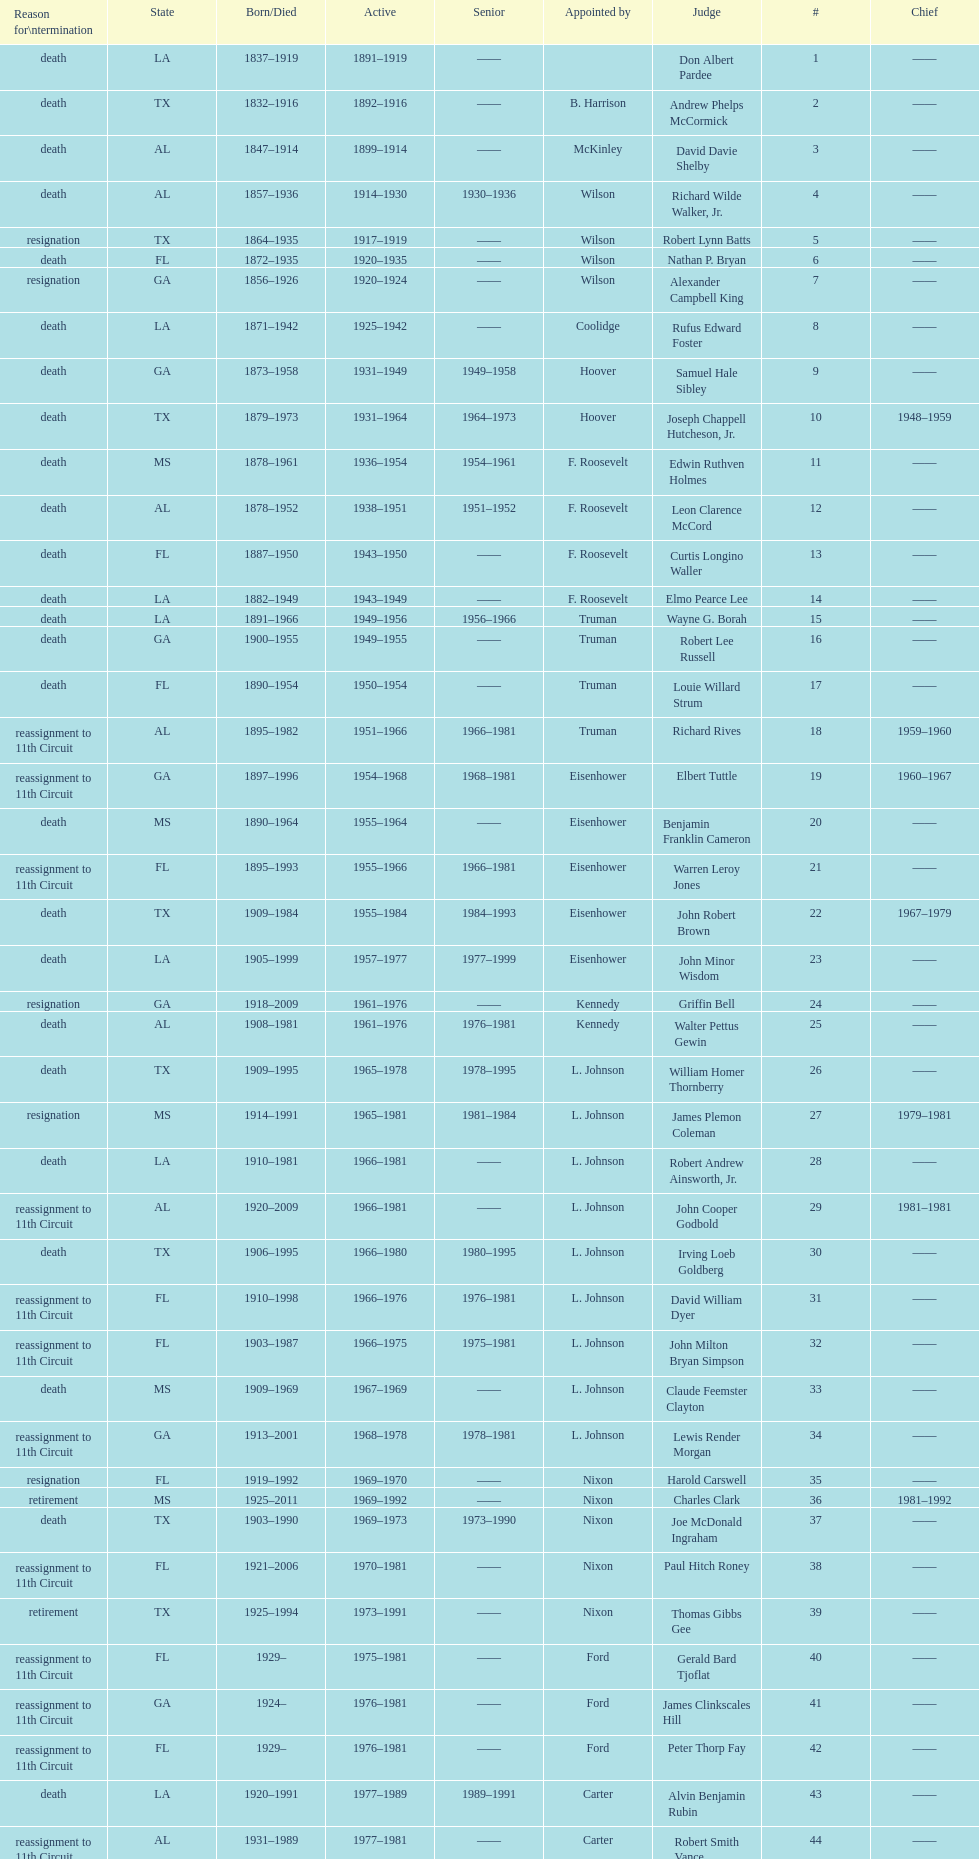Who was the first judge from florida to serve the position? Nathan P. Bryan. I'm looking to parse the entire table for insights. Could you assist me with that? {'header': ['Reason for\\ntermination', 'State', 'Born/Died', 'Active', 'Senior', 'Appointed by', 'Judge', '#', 'Chief'], 'rows': [['death', 'LA', '1837–1919', '1891–1919', '——', '', 'Don Albert Pardee', '1', '——'], ['death', 'TX', '1832–1916', '1892–1916', '——', 'B. Harrison', 'Andrew Phelps McCormick', '2', '——'], ['death', 'AL', '1847–1914', '1899–1914', '——', 'McKinley', 'David Davie Shelby', '3', '——'], ['death', 'AL', '1857–1936', '1914–1930', '1930–1936', 'Wilson', 'Richard Wilde Walker, Jr.', '4', '——'], ['resignation', 'TX', '1864–1935', '1917–1919', '——', 'Wilson', 'Robert Lynn Batts', '5', '——'], ['death', 'FL', '1872–1935', '1920–1935', '——', 'Wilson', 'Nathan P. Bryan', '6', '——'], ['resignation', 'GA', '1856–1926', '1920–1924', '——', 'Wilson', 'Alexander Campbell King', '7', '——'], ['death', 'LA', '1871–1942', '1925–1942', '——', 'Coolidge', 'Rufus Edward Foster', '8', '——'], ['death', 'GA', '1873–1958', '1931–1949', '1949–1958', 'Hoover', 'Samuel Hale Sibley', '9', '——'], ['death', 'TX', '1879–1973', '1931–1964', '1964–1973', 'Hoover', 'Joseph Chappell Hutcheson, Jr.', '10', '1948–1959'], ['death', 'MS', '1878–1961', '1936–1954', '1954–1961', 'F. Roosevelt', 'Edwin Ruthven Holmes', '11', '——'], ['death', 'AL', '1878–1952', '1938–1951', '1951–1952', 'F. Roosevelt', 'Leon Clarence McCord', '12', '——'], ['death', 'FL', '1887–1950', '1943–1950', '——', 'F. Roosevelt', 'Curtis Longino Waller', '13', '——'], ['death', 'LA', '1882–1949', '1943–1949', '——', 'F. Roosevelt', 'Elmo Pearce Lee', '14', '——'], ['death', 'LA', '1891–1966', '1949–1956', '1956–1966', 'Truman', 'Wayne G. Borah', '15', '——'], ['death', 'GA', '1900–1955', '1949–1955', '——', 'Truman', 'Robert Lee Russell', '16', '——'], ['death', 'FL', '1890–1954', '1950–1954', '——', 'Truman', 'Louie Willard Strum', '17', '——'], ['reassignment to 11th Circuit', 'AL', '1895–1982', '1951–1966', '1966–1981', 'Truman', 'Richard Rives', '18', '1959–1960'], ['reassignment to 11th Circuit', 'GA', '1897–1996', '1954–1968', '1968–1981', 'Eisenhower', 'Elbert Tuttle', '19', '1960–1967'], ['death', 'MS', '1890–1964', '1955–1964', '——', 'Eisenhower', 'Benjamin Franklin Cameron', '20', '——'], ['reassignment to 11th Circuit', 'FL', '1895–1993', '1955–1966', '1966–1981', 'Eisenhower', 'Warren Leroy Jones', '21', '——'], ['death', 'TX', '1909–1984', '1955–1984', '1984–1993', 'Eisenhower', 'John Robert Brown', '22', '1967–1979'], ['death', 'LA', '1905–1999', '1957–1977', '1977–1999', 'Eisenhower', 'John Minor Wisdom', '23', '——'], ['resignation', 'GA', '1918–2009', '1961–1976', '——', 'Kennedy', 'Griffin Bell', '24', '——'], ['death', 'AL', '1908–1981', '1961–1976', '1976–1981', 'Kennedy', 'Walter Pettus Gewin', '25', '——'], ['death', 'TX', '1909–1995', '1965–1978', '1978–1995', 'L. Johnson', 'William Homer Thornberry', '26', '——'], ['resignation', 'MS', '1914–1991', '1965–1981', '1981–1984', 'L. Johnson', 'James Plemon Coleman', '27', '1979–1981'], ['death', 'LA', '1910–1981', '1966–1981', '——', 'L. Johnson', 'Robert Andrew Ainsworth, Jr.', '28', '——'], ['reassignment to 11th Circuit', 'AL', '1920–2009', '1966–1981', '——', 'L. Johnson', 'John Cooper Godbold', '29', '1981–1981'], ['death', 'TX', '1906–1995', '1966–1980', '1980–1995', 'L. Johnson', 'Irving Loeb Goldberg', '30', '——'], ['reassignment to 11th Circuit', 'FL', '1910–1998', '1966–1976', '1976–1981', 'L. Johnson', 'David William Dyer', '31', '——'], ['reassignment to 11th Circuit', 'FL', '1903–1987', '1966–1975', '1975–1981', 'L. Johnson', 'John Milton Bryan Simpson', '32', '——'], ['death', 'MS', '1909–1969', '1967–1969', '——', 'L. Johnson', 'Claude Feemster Clayton', '33', '——'], ['reassignment to 11th Circuit', 'GA', '1913–2001', '1968–1978', '1978–1981', 'L. Johnson', 'Lewis Render Morgan', '34', '——'], ['resignation', 'FL', '1919–1992', '1969–1970', '——', 'Nixon', 'Harold Carswell', '35', '——'], ['retirement', 'MS', '1925–2011', '1969–1992', '——', 'Nixon', 'Charles Clark', '36', '1981–1992'], ['death', 'TX', '1903–1990', '1969–1973', '1973–1990', 'Nixon', 'Joe McDonald Ingraham', '37', '——'], ['reassignment to 11th Circuit', 'FL', '1921–2006', '1970–1981', '——', 'Nixon', 'Paul Hitch Roney', '38', '——'], ['retirement', 'TX', '1925–1994', '1973–1991', '——', 'Nixon', 'Thomas Gibbs Gee', '39', '——'], ['reassignment to 11th Circuit', 'FL', '1929–', '1975–1981', '——', 'Ford', 'Gerald Bard Tjoflat', '40', '——'], ['reassignment to 11th Circuit', 'GA', '1924–', '1976–1981', '——', 'Ford', 'James Clinkscales Hill', '41', '——'], ['reassignment to 11th Circuit', 'FL', '1929–', '1976–1981', '——', 'Ford', 'Peter Thorp Fay', '42', '——'], ['death', 'LA', '1920–1991', '1977–1989', '1989–1991', 'Carter', 'Alvin Benjamin Rubin', '43', '——'], ['reassignment to 11th Circuit', 'AL', '1931–1989', '1977–1981', '——', 'Carter', 'Robert Smith Vance', '44', '——'], ['reassignment to 11th Circuit', 'GA', '1920–', '1979–1981', '——', 'Carter', 'Phyllis A. Kravitch', '45', '——'], ['reassignment to 11th Circuit', 'AL', '1918–1999', '1979–1981', '——', 'Carter', 'Frank Minis Johnson', '46', '——'], ['reassignment to 11th Circuit', 'GA', '1936–', '1979–1981', '——', 'Carter', 'R. Lanier Anderson III', '47', '——'], ['death', 'TX', '1915–2004', '1979–1982', '1982–2004', 'Carter', 'Reynaldo Guerra Garza', '48', '——'], ['reassignment to 11th Circuit', 'FL', '1932–', '1979–1981', '——', 'Carter', 'Joseph Woodrow Hatchett', '49', '——'], ['reassignment to 11th Circuit', 'GA', '1920–1999', '1979–1981', '——', 'Carter', 'Albert John Henderson', '50', '——'], ['death', 'LA', '1932–2002', '1979–1999', '1999–2002', 'Carter', 'Henry Anthony Politz', '52', '1992–1999'], ['death', 'TX', '1920–2002', '1979–1991', '1991–2002', 'Carter', 'Samuel D. Johnson, Jr.', '54', '——'], ['death', 'LA', '1920–1986', '1979–1986', '——', 'Carter', 'Albert Tate, Jr.', '55', '——'], ['reassignment to 11th Circuit', 'GA', '1920–2005', '1979–1981', '——', 'Carter', 'Thomas Alonzo Clark', '56', '——'], ['death', 'TX', '1916–1993', '1980–1990', '1990–1993', 'Carter', 'Jerre Stockton Williams', '57', '——'], ['death', 'TX', '1931–2011', '1981–1997', '1997–2011', 'Reagan', 'William Lockhart Garwood', '58', '——'], ['death', 'TX', '1928–1987', '1984–1987', '——', 'Reagan', 'Robert Madden Hill', '62', '——'], ['retirement', 'LA', '1933-', '1988–1999', '1999–2011', 'Reagan', 'John Malcolm Duhé, Jr.', '65', '——'], ['retirement', 'TX', '1937–', '1994–2002', '——', 'Clinton', 'Robert Manley Parker', '72', '——'], ['retirement', 'MS', '1937–', '2004–2004', '——', 'G.W. Bush', 'Charles W. Pickering', '76', '——']]} 